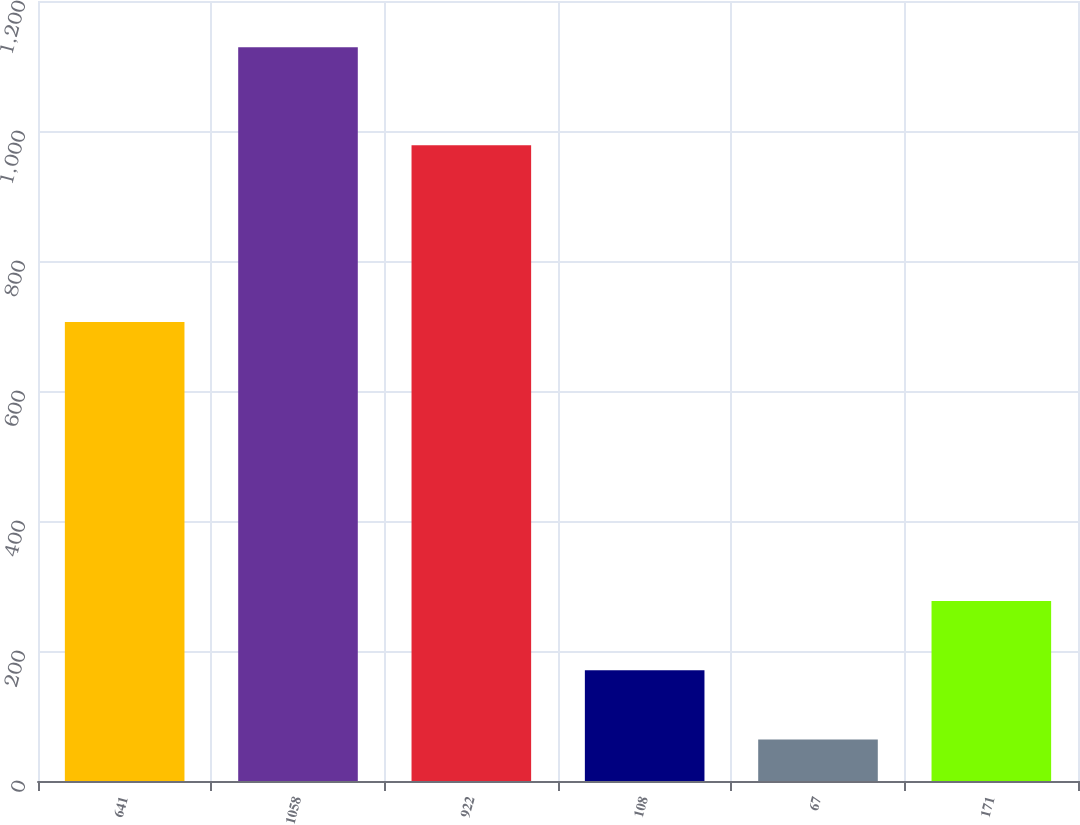<chart> <loc_0><loc_0><loc_500><loc_500><bar_chart><fcel>641<fcel>1058<fcel>922<fcel>108<fcel>67<fcel>171<nl><fcel>706<fcel>1129<fcel>978<fcel>170.5<fcel>64<fcel>277<nl></chart> 